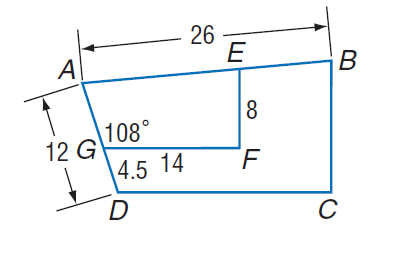Answer the mathemtical geometry problem and directly provide the correct option letter.
Question: Polygon A B C D \sim polygon A E F G, m \angle A G F = 108, G F = 14, A D = 12, D G = 4.5, E F = 8, and A B = 26. Find B C.
Choices: A: 4.5 B: 12 C: 12.8 D: 100 C 